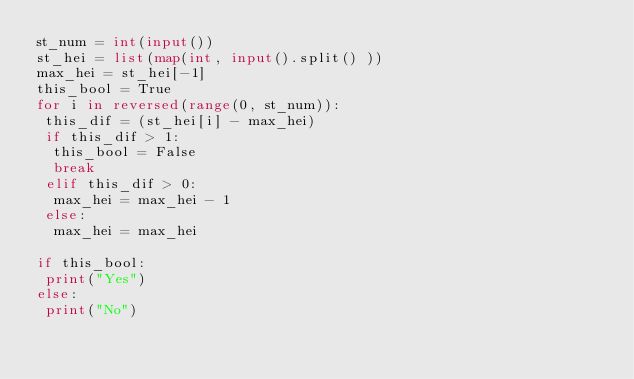Convert code to text. <code><loc_0><loc_0><loc_500><loc_500><_Python_>st_num = int(input())
st_hei = list(map(int, input().split() ))
max_hei = st_hei[-1]
this_bool = True
for i in reversed(range(0, st_num)):
 this_dif = (st_hei[i] - max_hei)
 if this_dif > 1:
  this_bool = False
  break
 elif this_dif > 0:
  max_hei = max_hei - 1
 else:
  max_hei = max_hei

if this_bool:
 print("Yes")
else:
 print("No")
</code> 